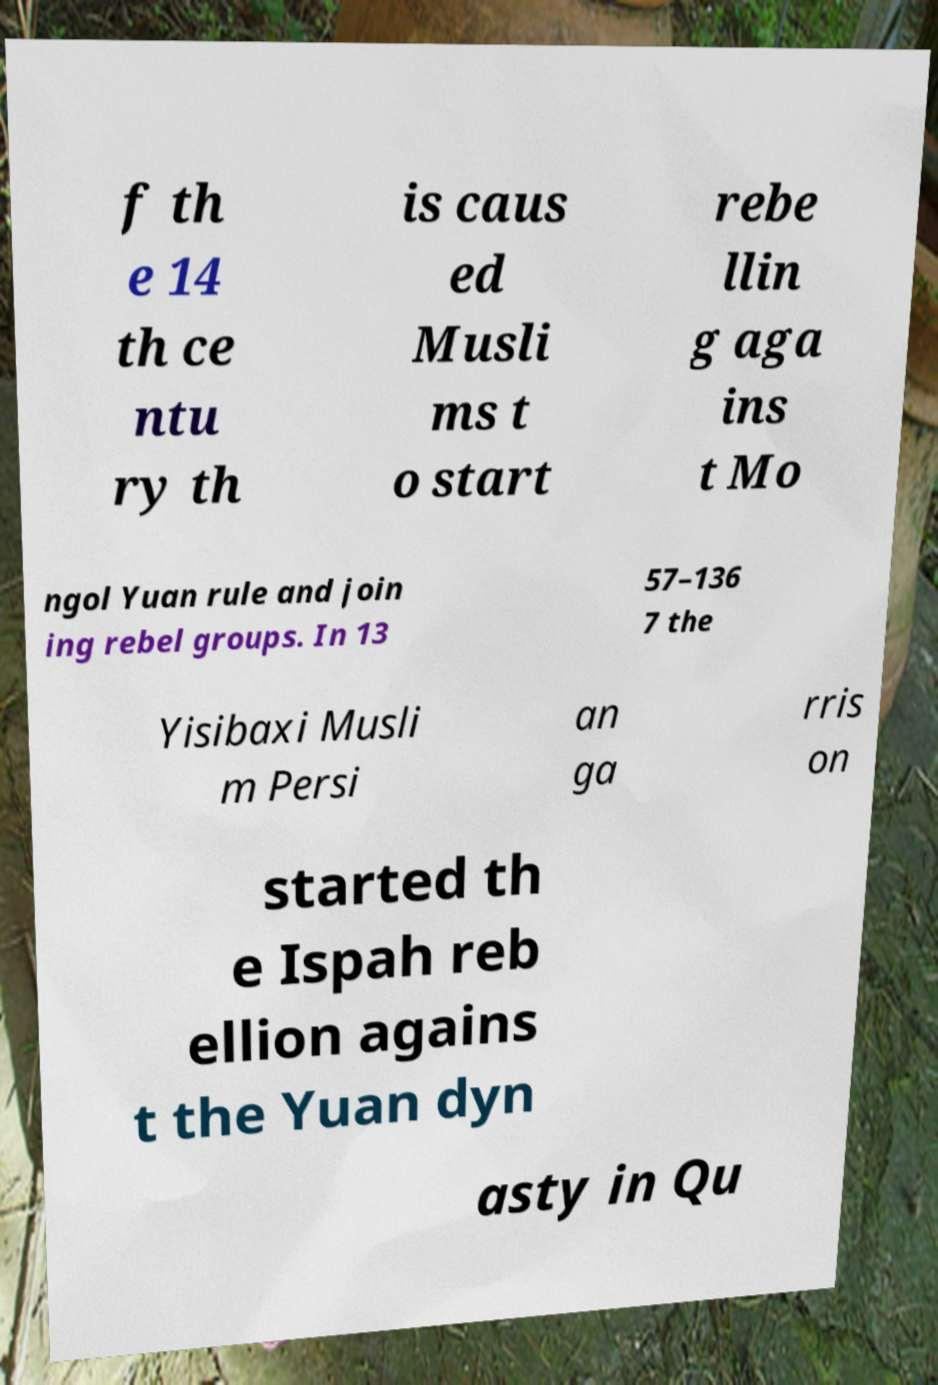Please identify and transcribe the text found in this image. f th e 14 th ce ntu ry th is caus ed Musli ms t o start rebe llin g aga ins t Mo ngol Yuan rule and join ing rebel groups. In 13 57–136 7 the Yisibaxi Musli m Persi an ga rris on started th e Ispah reb ellion agains t the Yuan dyn asty in Qu 